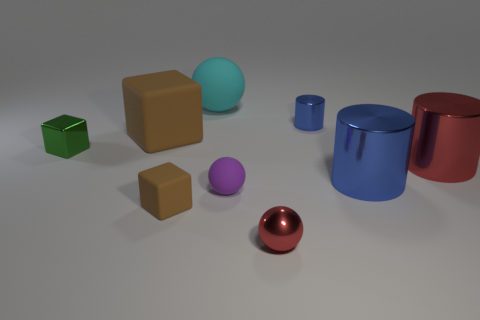How does the arrangement of objects affect the composition of the image? The objects are arranged in a manner that creates balance without symmetry. Each object's unique size, shape, and color adds to the visual interest, leading the viewer's eye across the image. The spatial distribution provides a sense of depth and dimensionality. 